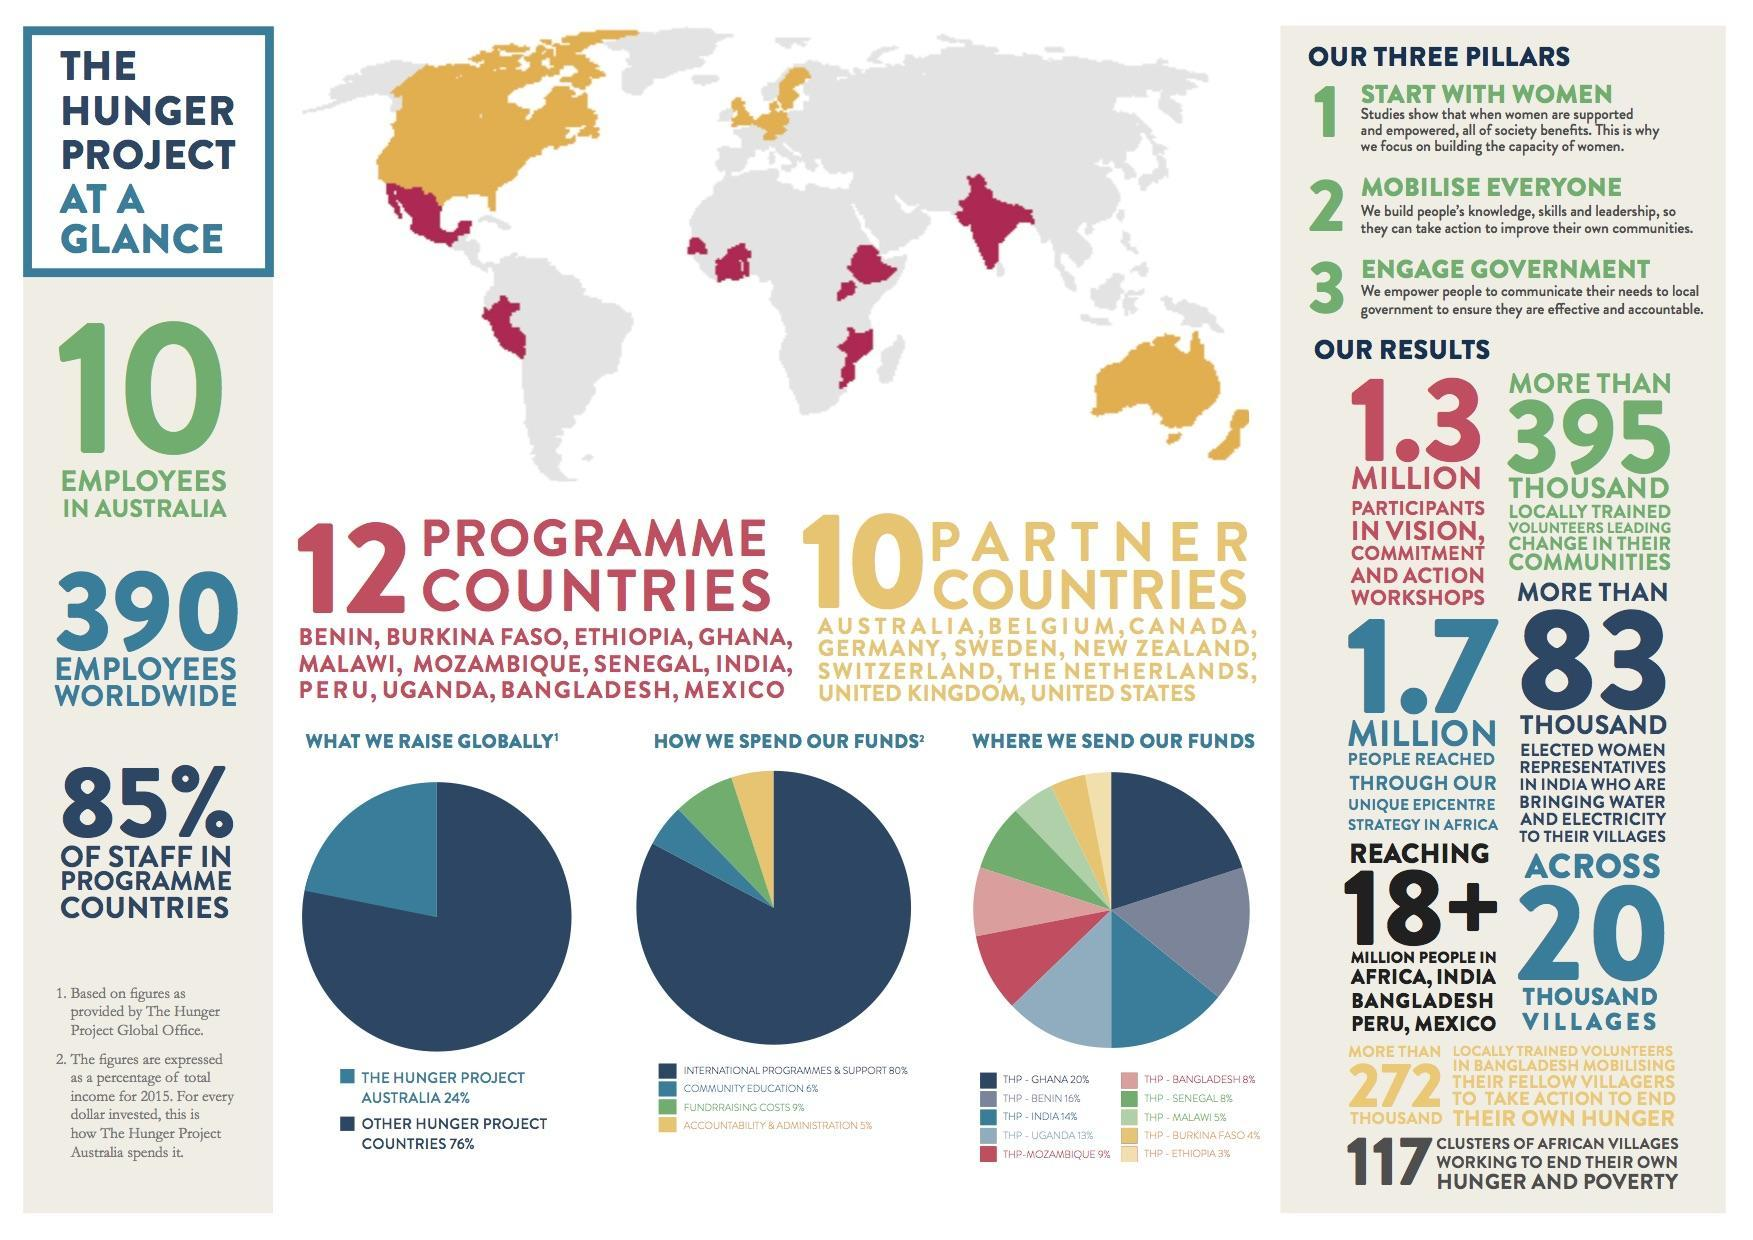Which has the highest share-community education, international programmes & support?
Answer the question with a short phrase. international programmes & support What is the percentage of community education and fundraising costs, taken together? 15% Which has the highest share-the hunger project Australia, other hunger project countries? other hunger project countries What is the percentage of community education and accountability & administration, taken together? 11% 